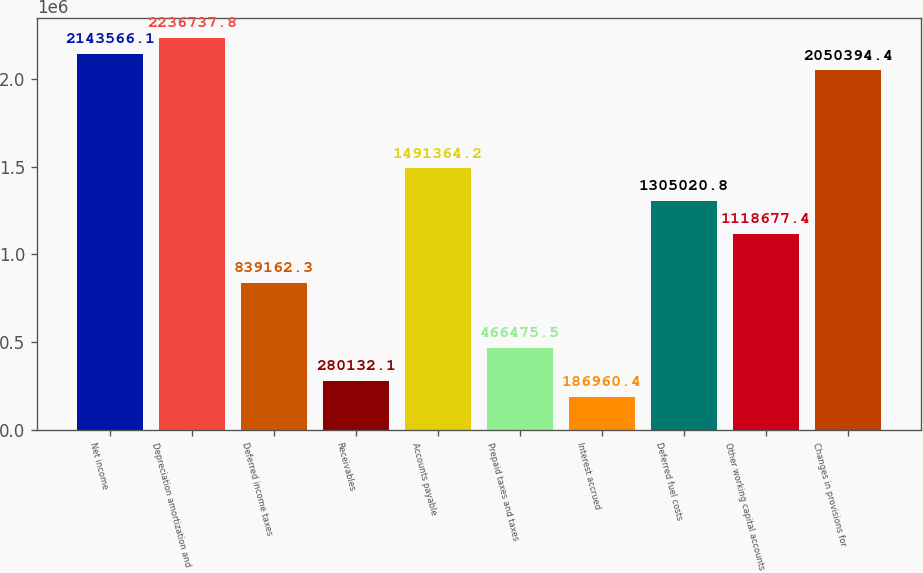Convert chart to OTSL. <chart><loc_0><loc_0><loc_500><loc_500><bar_chart><fcel>Net income<fcel>Depreciation amortization and<fcel>Deferred income taxes<fcel>Receivables<fcel>Accounts payable<fcel>Prepaid taxes and taxes<fcel>Interest accrued<fcel>Deferred fuel costs<fcel>Other working capital accounts<fcel>Changes in provisions for<nl><fcel>2.14357e+06<fcel>2.23674e+06<fcel>839162<fcel>280132<fcel>1.49136e+06<fcel>466476<fcel>186960<fcel>1.30502e+06<fcel>1.11868e+06<fcel>2.05039e+06<nl></chart> 